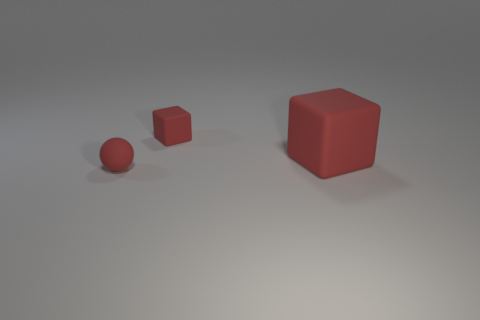Add 3 matte blocks. How many objects exist? 6 Subtract all cubes. How many objects are left? 1 Subtract all balls. Subtract all small red rubber blocks. How many objects are left? 1 Add 3 large blocks. How many large blocks are left? 4 Add 1 red rubber balls. How many red rubber balls exist? 2 Subtract 0 red cylinders. How many objects are left? 3 